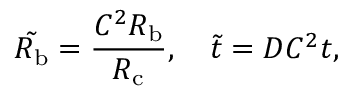<formula> <loc_0><loc_0><loc_500><loc_500>\tilde { R _ { b } } = \frac { C ^ { 2 } R _ { b } } { R _ { c } } , \quad \tilde { t } = D C ^ { 2 } t ,</formula> 